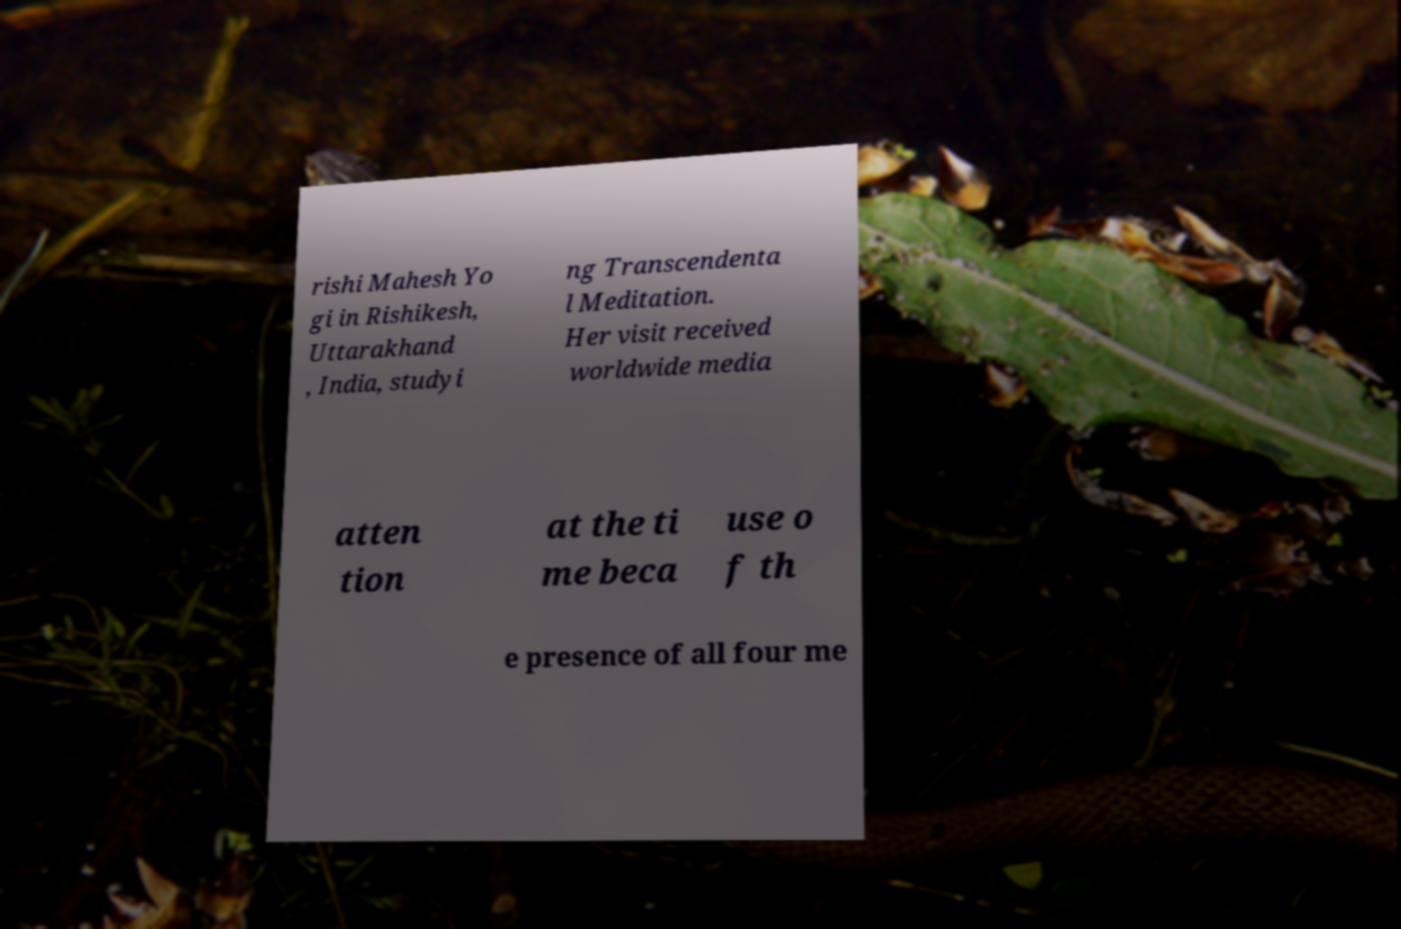Could you assist in decoding the text presented in this image and type it out clearly? rishi Mahesh Yo gi in Rishikesh, Uttarakhand , India, studyi ng Transcendenta l Meditation. Her visit received worldwide media atten tion at the ti me beca use o f th e presence of all four me 